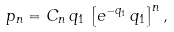Convert formula to latex. <formula><loc_0><loc_0><loc_500><loc_500>p _ { n } = C _ { n } \, q _ { 1 } \, \left [ e ^ { - q _ { 1 } } \, q _ { 1 } \right ] ^ { n } ,</formula> 